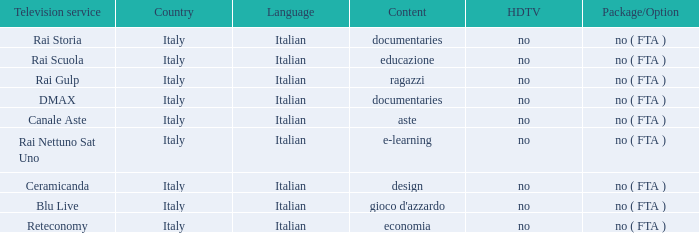What is the hdtv channel for the rai nettuno sat uno television provider? No. I'm looking to parse the entire table for insights. Could you assist me with that? {'header': ['Television service', 'Country', 'Language', 'Content', 'HDTV', 'Package/Option'], 'rows': [['Rai Storia', 'Italy', 'Italian', 'documentaries', 'no', 'no ( FTA )'], ['Rai Scuola', 'Italy', 'Italian', 'educazione', 'no', 'no ( FTA )'], ['Rai Gulp', 'Italy', 'Italian', 'ragazzi', 'no', 'no ( FTA )'], ['DMAX', 'Italy', 'Italian', 'documentaries', 'no', 'no ( FTA )'], ['Canale Aste', 'Italy', 'Italian', 'aste', 'no', 'no ( FTA )'], ['Rai Nettuno Sat Uno', 'Italy', 'Italian', 'e-learning', 'no', 'no ( FTA )'], ['Ceramicanda', 'Italy', 'Italian', 'design', 'no', 'no ( FTA )'], ['Blu Live', 'Italy', 'Italian', "gioco d'azzardo", 'no', 'no ( FTA )'], ['Reteconomy', 'Italy', 'Italian', 'economia', 'no', 'no ( FTA )']]} 